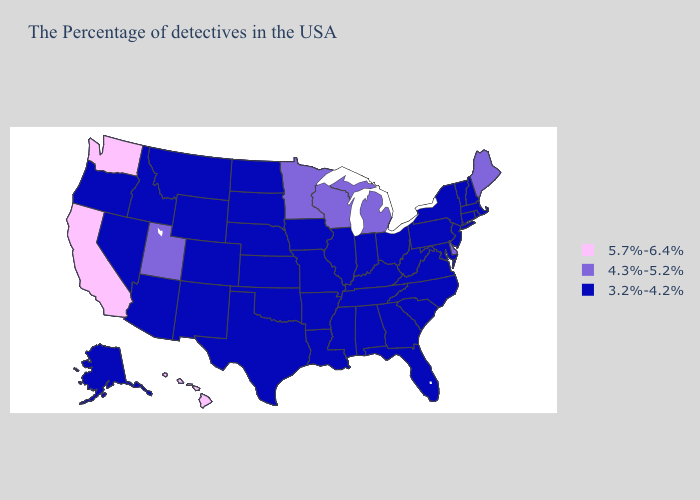Among the states that border Virginia , which have the highest value?
Concise answer only. Maryland, North Carolina, West Virginia, Kentucky, Tennessee. Name the states that have a value in the range 3.2%-4.2%?
Short answer required. Massachusetts, Rhode Island, New Hampshire, Vermont, Connecticut, New York, New Jersey, Maryland, Pennsylvania, Virginia, North Carolina, South Carolina, West Virginia, Ohio, Florida, Georgia, Kentucky, Indiana, Alabama, Tennessee, Illinois, Mississippi, Louisiana, Missouri, Arkansas, Iowa, Kansas, Nebraska, Oklahoma, Texas, South Dakota, North Dakota, Wyoming, Colorado, New Mexico, Montana, Arizona, Idaho, Nevada, Oregon, Alaska. What is the lowest value in states that border New Jersey?
Quick response, please. 3.2%-4.2%. Does New Hampshire have the highest value in the Northeast?
Keep it brief. No. Among the states that border New Jersey , does Delaware have the lowest value?
Give a very brief answer. No. Name the states that have a value in the range 3.2%-4.2%?
Give a very brief answer. Massachusetts, Rhode Island, New Hampshire, Vermont, Connecticut, New York, New Jersey, Maryland, Pennsylvania, Virginia, North Carolina, South Carolina, West Virginia, Ohio, Florida, Georgia, Kentucky, Indiana, Alabama, Tennessee, Illinois, Mississippi, Louisiana, Missouri, Arkansas, Iowa, Kansas, Nebraska, Oklahoma, Texas, South Dakota, North Dakota, Wyoming, Colorado, New Mexico, Montana, Arizona, Idaho, Nevada, Oregon, Alaska. Which states have the lowest value in the USA?
Answer briefly. Massachusetts, Rhode Island, New Hampshire, Vermont, Connecticut, New York, New Jersey, Maryland, Pennsylvania, Virginia, North Carolina, South Carolina, West Virginia, Ohio, Florida, Georgia, Kentucky, Indiana, Alabama, Tennessee, Illinois, Mississippi, Louisiana, Missouri, Arkansas, Iowa, Kansas, Nebraska, Oklahoma, Texas, South Dakota, North Dakota, Wyoming, Colorado, New Mexico, Montana, Arizona, Idaho, Nevada, Oregon, Alaska. What is the highest value in the Northeast ?
Give a very brief answer. 4.3%-5.2%. Which states have the lowest value in the USA?
Be succinct. Massachusetts, Rhode Island, New Hampshire, Vermont, Connecticut, New York, New Jersey, Maryland, Pennsylvania, Virginia, North Carolina, South Carolina, West Virginia, Ohio, Florida, Georgia, Kentucky, Indiana, Alabama, Tennessee, Illinois, Mississippi, Louisiana, Missouri, Arkansas, Iowa, Kansas, Nebraska, Oklahoma, Texas, South Dakota, North Dakota, Wyoming, Colorado, New Mexico, Montana, Arizona, Idaho, Nevada, Oregon, Alaska. What is the lowest value in the USA?
Short answer required. 3.2%-4.2%. What is the value of Kansas?
Concise answer only. 3.2%-4.2%. Name the states that have a value in the range 5.7%-6.4%?
Write a very short answer. California, Washington, Hawaii. What is the value of New York?
Short answer required. 3.2%-4.2%. 